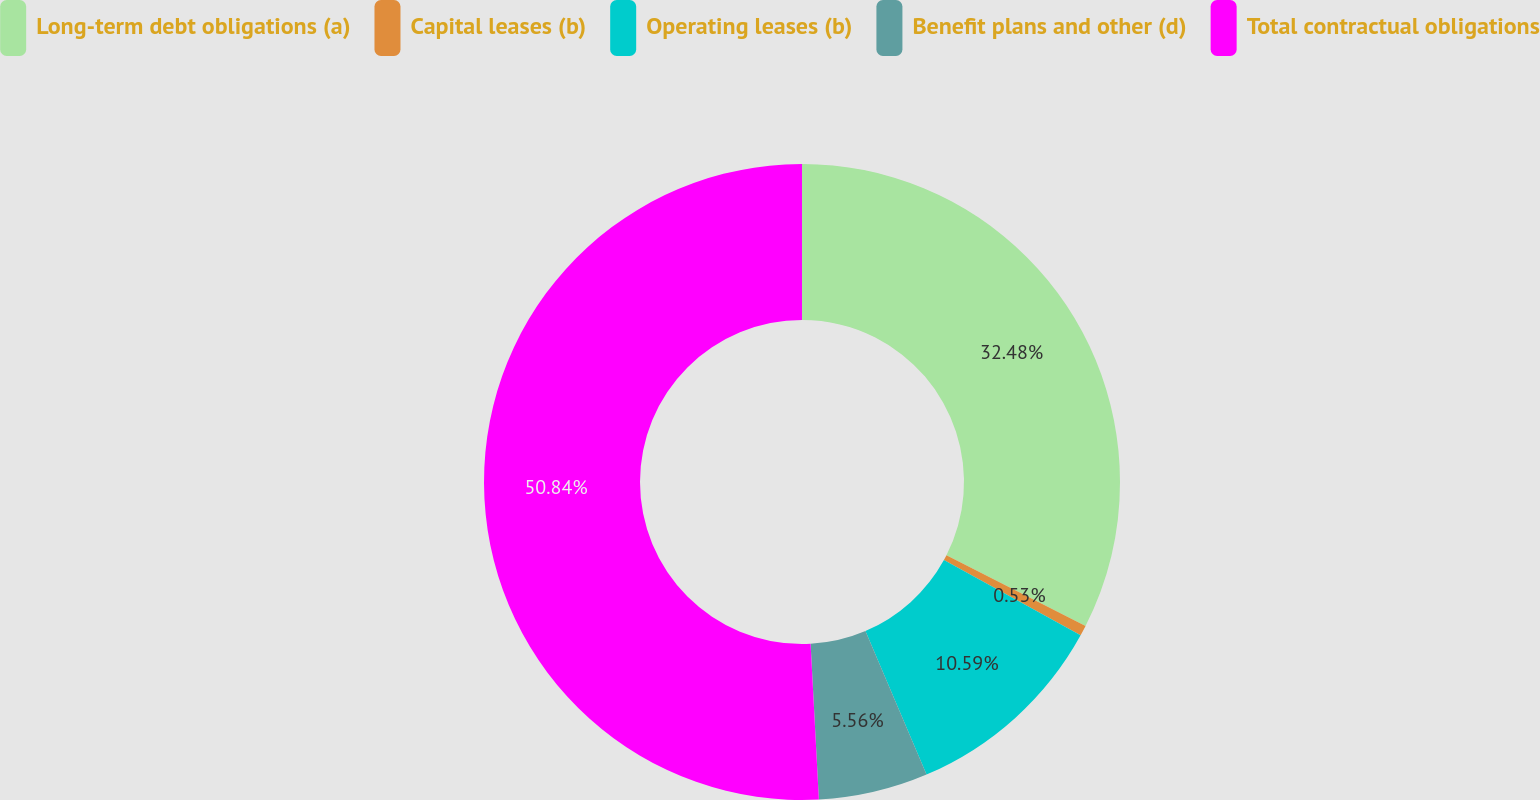Convert chart. <chart><loc_0><loc_0><loc_500><loc_500><pie_chart><fcel>Long-term debt obligations (a)<fcel>Capital leases (b)<fcel>Operating leases (b)<fcel>Benefit plans and other (d)<fcel>Total contractual obligations<nl><fcel>32.48%<fcel>0.53%<fcel>10.59%<fcel>5.56%<fcel>50.85%<nl></chart> 